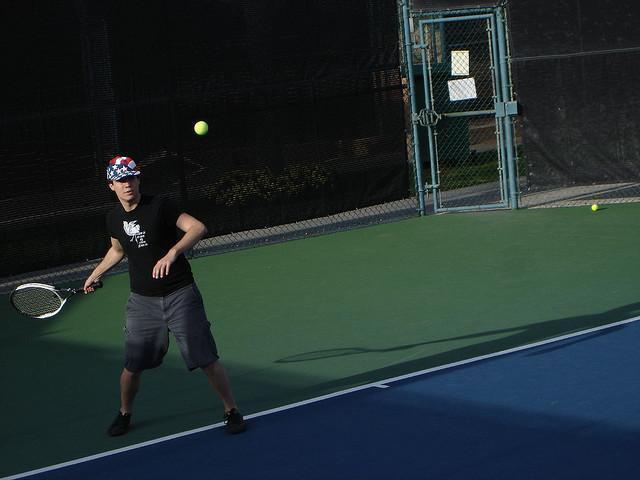How many people are there?
Give a very brief answer. 1. 